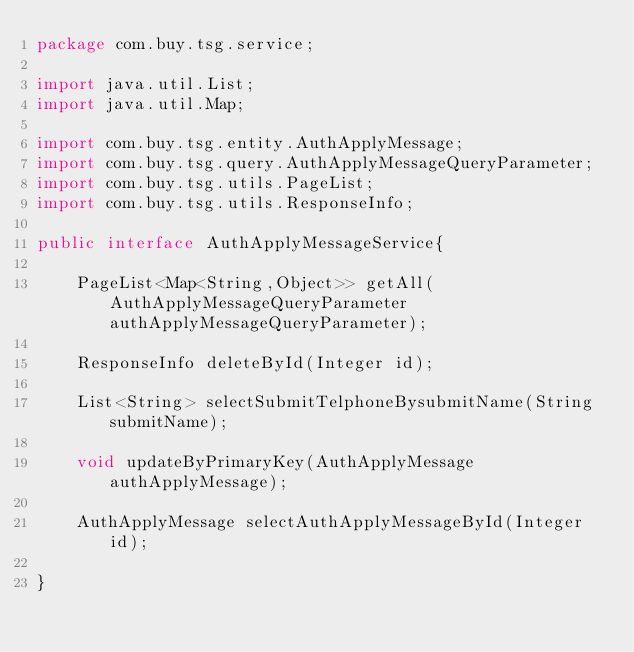Convert code to text. <code><loc_0><loc_0><loc_500><loc_500><_Java_>package com.buy.tsg.service;

import java.util.List;
import java.util.Map;

import com.buy.tsg.entity.AuthApplyMessage;
import com.buy.tsg.query.AuthApplyMessageQueryParameter;
import com.buy.tsg.utils.PageList;
import com.buy.tsg.utils.ResponseInfo;

public interface AuthApplyMessageService{
	
	PageList<Map<String,Object>> getAll(AuthApplyMessageQueryParameter authApplyMessageQueryParameter);
	
	ResponseInfo deleteById(Integer id);
	
    List<String> selectSubmitTelphoneBysubmitName(String submitName);
    
    void updateByPrimaryKey(AuthApplyMessage authApplyMessage);
    
    AuthApplyMessage selectAuthApplyMessageById(Integer id);

}
</code> 